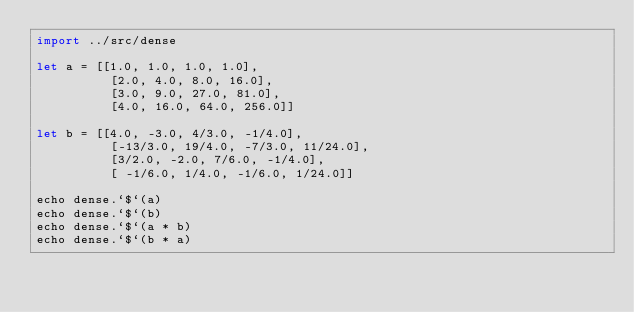Convert code to text. <code><loc_0><loc_0><loc_500><loc_500><_Nim_>import ../src/dense

let a = [[1.0, 1.0, 1.0, 1.0],
          [2.0, 4.0, 8.0, 16.0],
          [3.0, 9.0, 27.0, 81.0],
          [4.0, 16.0, 64.0, 256.0]]

let b = [[4.0, -3.0, 4/3.0, -1/4.0],
          [-13/3.0, 19/4.0, -7/3.0, 11/24.0],
          [3/2.0, -2.0, 7/6.0, -1/4.0],
          [ -1/6.0, 1/4.0, -1/6.0, 1/24.0]]

echo dense.`$`(a)
echo dense.`$`(b)
echo dense.`$`(a * b)
echo dense.`$`(b * a)
</code> 